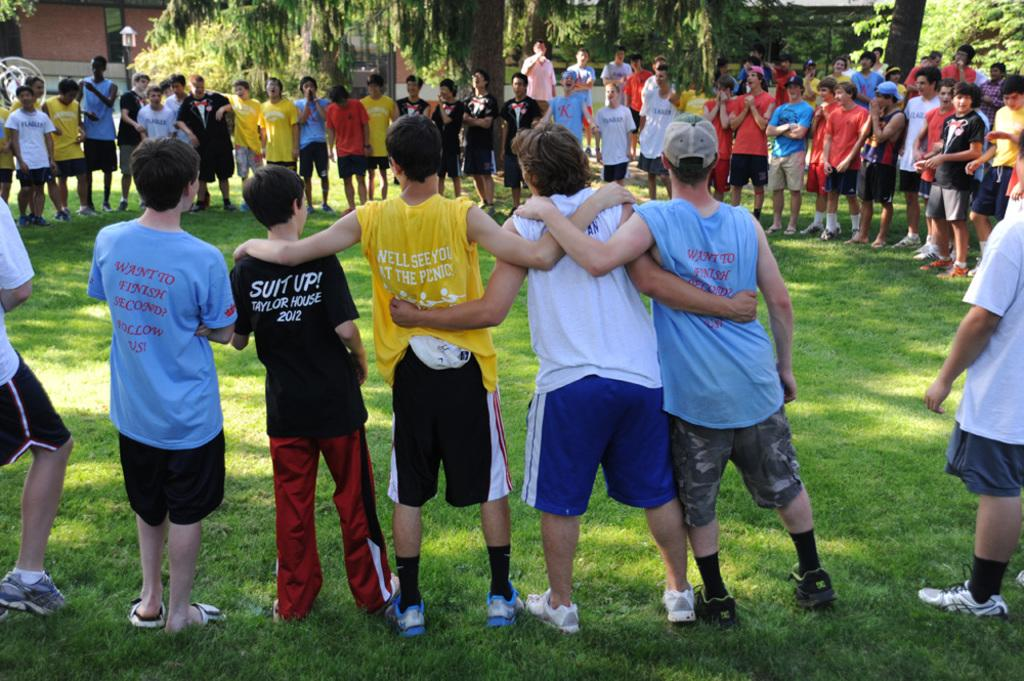<image>
Create a compact narrative representing the image presented. Several kids stand around in a circle. One is wearing a black shirt that reads "suit up!" 